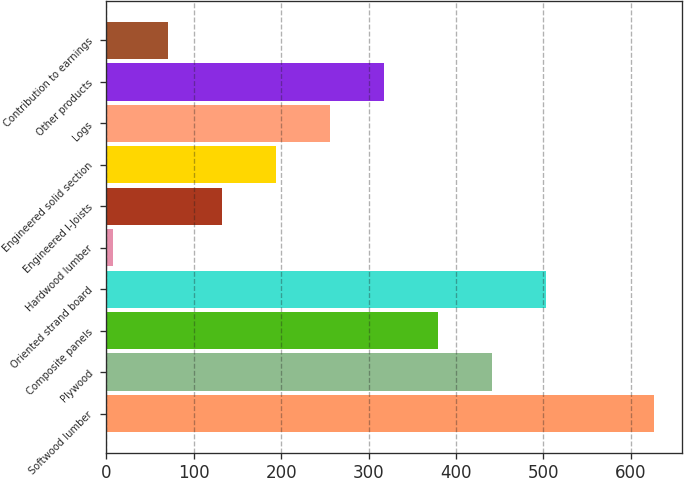<chart> <loc_0><loc_0><loc_500><loc_500><bar_chart><fcel>Softwood lumber<fcel>Plywood<fcel>Composite panels<fcel>Oriented strand board<fcel>Hardwood lumber<fcel>Engineered I-Joists<fcel>Engineered solid section<fcel>Logs<fcel>Other products<fcel>Contribution to earnings<nl><fcel>627<fcel>441.3<fcel>379.4<fcel>503.2<fcel>8<fcel>131.8<fcel>193.7<fcel>255.6<fcel>317.5<fcel>69.9<nl></chart> 